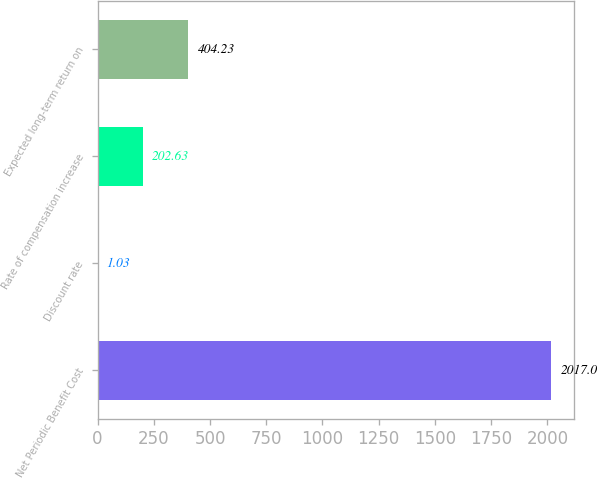<chart> <loc_0><loc_0><loc_500><loc_500><bar_chart><fcel>Net Periodic Benefit Cost<fcel>Discount rate<fcel>Rate of compensation increase<fcel>Expected long-term return on<nl><fcel>2017<fcel>1.03<fcel>202.63<fcel>404.23<nl></chart> 